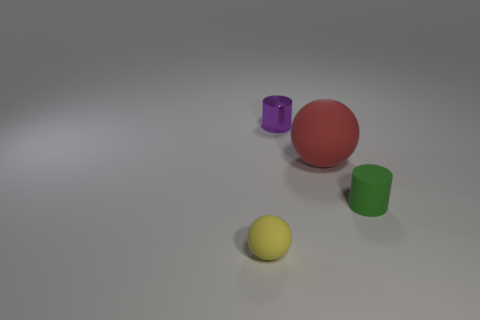Is the number of red matte objects behind the tiny purple cylinder the same as the number of tiny cylinders that are left of the green cylinder?
Offer a terse response. No. There is a small cylinder in front of the large sphere behind the yellow rubber thing; what number of green matte cylinders are on the right side of it?
Your answer should be very brief. 0. Is the number of tiny matte spheres to the left of the small shiny thing greater than the number of blue cylinders?
Your answer should be very brief. Yes. What number of objects are either small rubber things that are on the left side of the small purple shiny object or tiny matte things that are left of the tiny purple metallic cylinder?
Ensure brevity in your answer.  1. There is another sphere that is the same material as the tiny sphere; what is its size?
Offer a very short reply. Large. Do the small rubber thing left of the shiny object and the green thing have the same shape?
Offer a terse response. No. How many brown objects are small shiny cylinders or balls?
Offer a very short reply. 0. How many other objects are there of the same shape as the small purple metal object?
Ensure brevity in your answer.  1. There is a small thing that is both left of the tiny green cylinder and right of the yellow object; what is its shape?
Give a very brief answer. Cylinder. There is a small purple thing; are there any small things in front of it?
Give a very brief answer. Yes. 